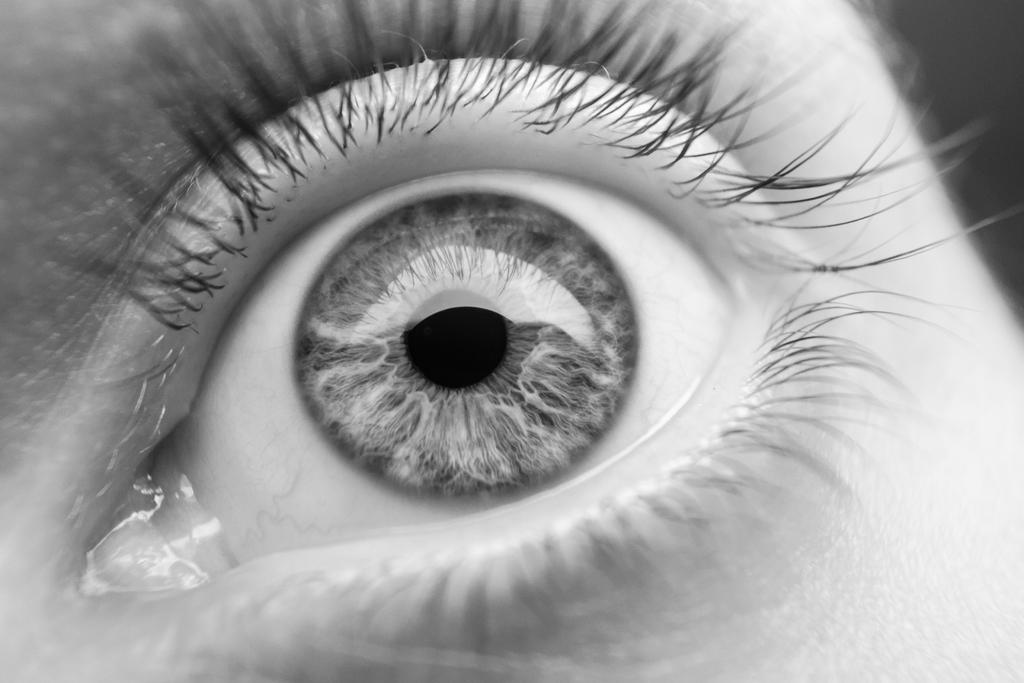What is the main subject of the image? The main subject of the image is a person's eye. What type of cloth is draped over the hill in the image? There is no cloth or hill present in the image; it features a person's eye. What color is the sweater worn by the person in the image? There is no sweater visible in the image, as it only features a person's eye. 